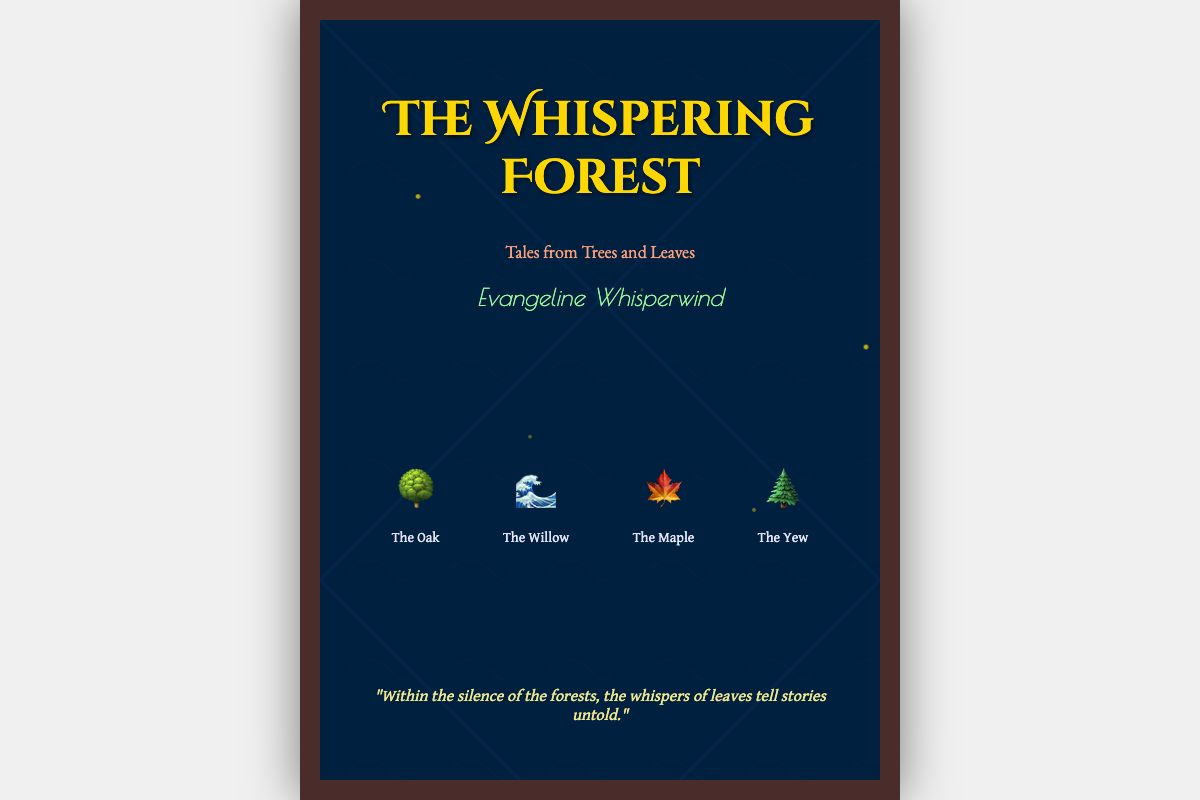What is the title of the book? The title is prominently displayed at the top of the cover.
Answer: The Whispering Forest Who is the author of the book? The author's name is located just below the subtitle.
Answer: Evangeline Whisperwind What is the subtitle of the book? The subtitle is placed directly under the title.
Answer: Tales from Trees and Leaves How many types of trees are illustrated on the cover? The cover includes illustrations and names of four types of trees.
Answer: Four What color is the title text? The color of the title text is specified in the document styles.
Answer: Gold What metaphor is implied in the quote on the cover? The quote suggests that there are untold stories found within nature's quietness.
Answer: Whispers of leaves Which tree is symbolized by the icon of a maple leaf? This tree type's visual representation is indicated by the corresponding emoji.
Answer: The Maple What is the background style of the book cover? The background includes a linear gradient and images related to nature.
Answer: Gradient with nature imagery What emotive element is suggested by the use of firefly animations? The firefly animations add a whimsical and enchanting touch to the cover's design.
Answer: Enchantment 